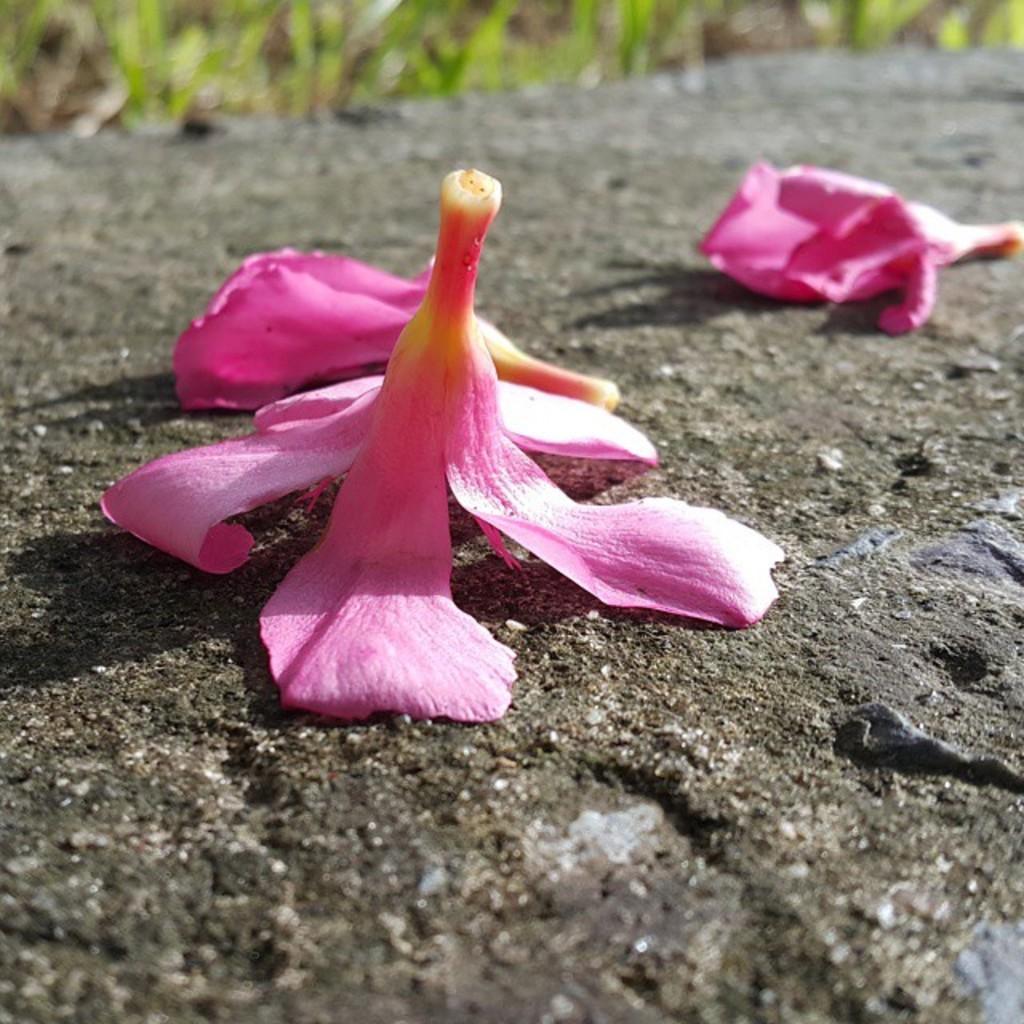Please provide a concise description of this image. In this picture we can see flowers are present on the road. At the top of the image we can see grass is there. 